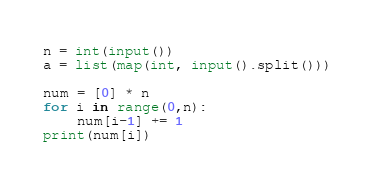<code> <loc_0><loc_0><loc_500><loc_500><_Python_>n = int(input())
a = list(map(int, input().split()))

num = [0] * n
for i in range(0,n):
    num[i-1] += 1
print(num[i])    </code> 